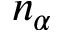Convert formula to latex. <formula><loc_0><loc_0><loc_500><loc_500>n _ { \alpha }</formula> 